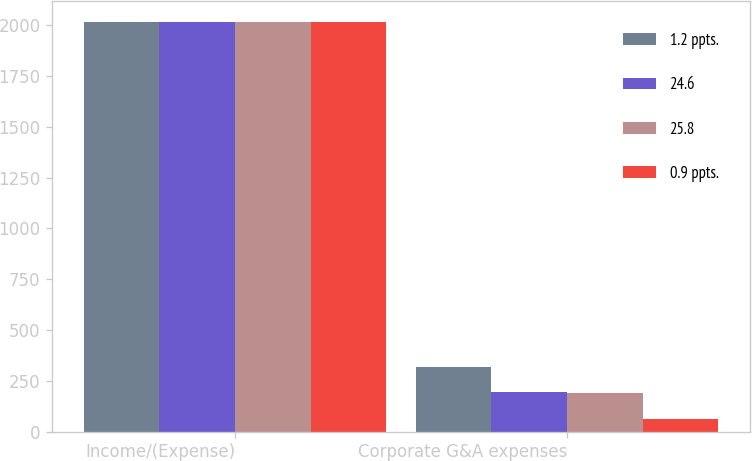<chart> <loc_0><loc_0><loc_500><loc_500><stacked_bar_chart><ecel><fcel>Income/(Expense)<fcel>Corporate G&A expenses<nl><fcel>1.2 ppts.<fcel>2016<fcel>316<nl><fcel>24.6<fcel>2015<fcel>196<nl><fcel>25.8<fcel>2014<fcel>189<nl><fcel>0.9 ppts.<fcel>2016<fcel>62<nl></chart> 